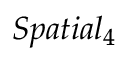<formula> <loc_0><loc_0><loc_500><loc_500>S p a t i a l _ { 4 }</formula> 